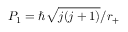Convert formula to latex. <formula><loc_0><loc_0><loc_500><loc_500>P _ { 1 } = \hbar { \sqrt } { j ( j + 1 ) } / r _ { + }</formula> 